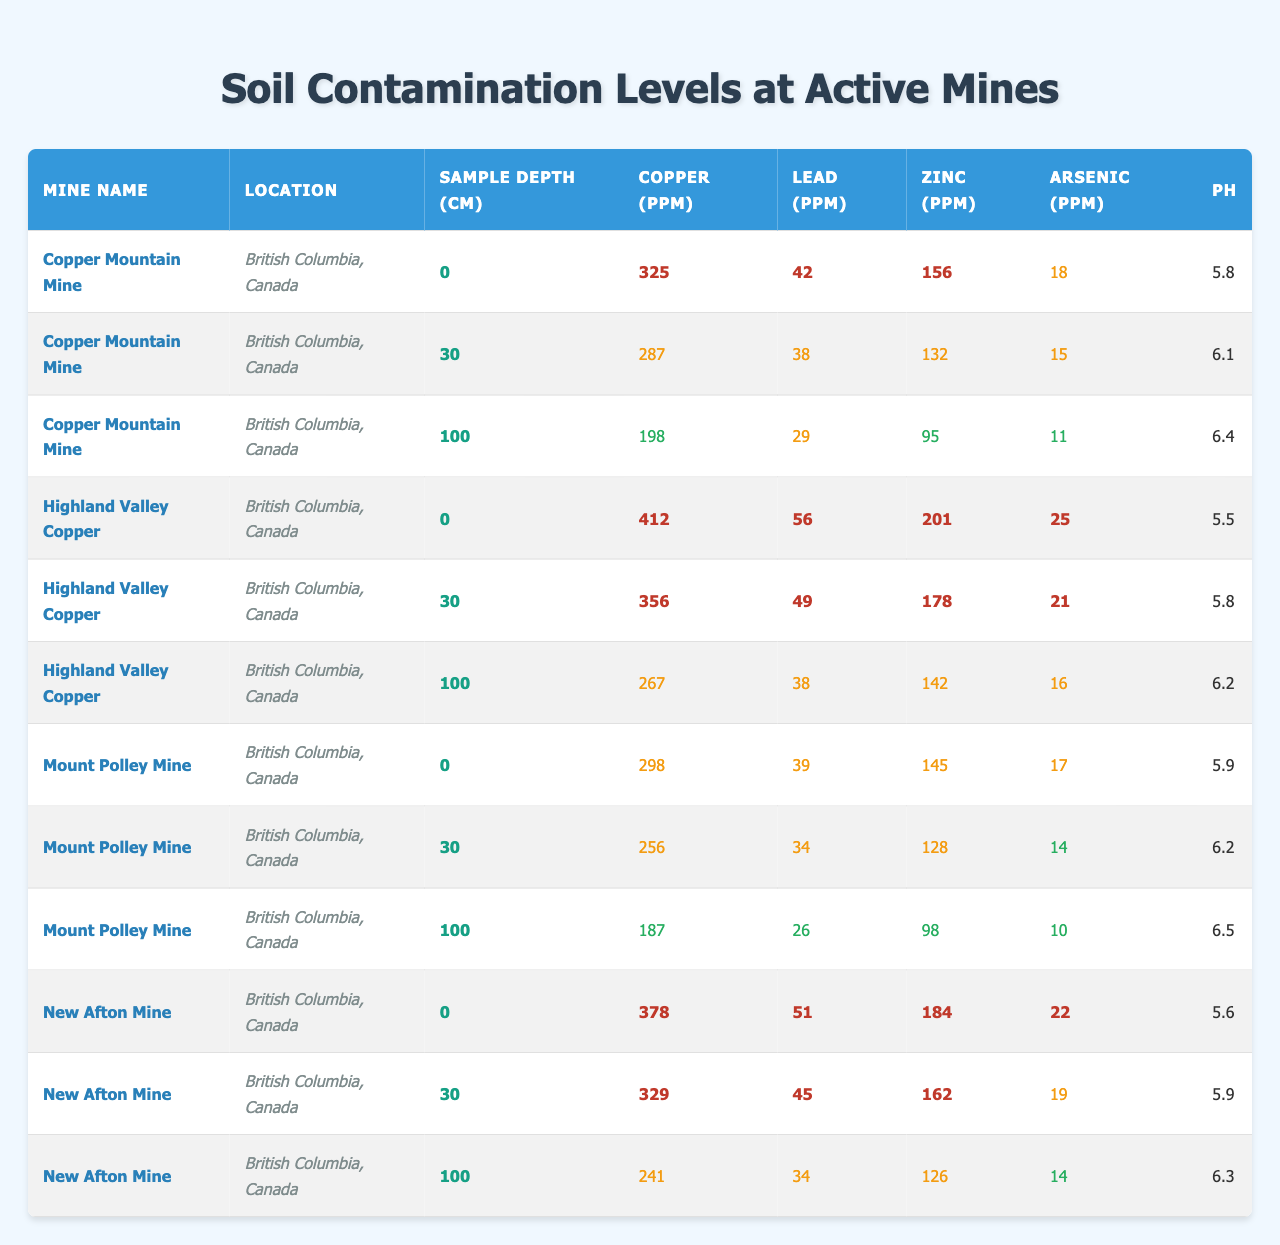What is the pH level recorded at Copper Mountain Mine at a depth of 100 cm? The pH level for Copper Mountain Mine at a depth of 100 cm is specifically listed in the table, where it shows a value of 6.4.
Answer: 6.4 Which mine shows the highest level of copper contamination at 30 cm depth? Looking at the table, Highland Valley Copper has the highest copper level at 30 cm with 356 ppm, compared to other mines at the same depth.
Answer: Highland Valley Copper What is the average arsenic contamination across all mines at a depth of 0 cm? By summing the arsenic levels at 0 cm for all four mines (18 + 25 + 17 + 22 = 82) and dividing by the number of mines (4), the average is calculated as 82/4 = 20.5.
Answer: 20.5 Is the lead contamination at Mount Polley Mine higher than that at New Afton Mine at 30 cm depth? Mount Polley Mine has 34 ppm of lead at 30 cm while New Afton Mine has 45 ppm at the same depth. Since 34 is less than 45, it confirms that the lead level at Mount Polley Mine is lower.
Answer: No At which depth does the New Afton Mine show a notable decrease in copper contamination from 0 cm to 100 cm? The New Afton Mine shows a decrease in copper from 378 ppm at 0 cm to 241 ppm at 100 cm. The difference (378 - 241) indicates a significant reduction of 137 ppm.
Answer: 100 cm What is the highest level of zinc contamination recorded, and at which mine and depth was it found? The table shows that the highest zinc contamination recorded is 201 ppm at Highland Valley Copper Mine at a depth of 0 cm.
Answer: Highland Valley Copper, 0 cm Are all mines showing an increase in pH level as the sampling depth increases? Reviewing the data, the pH levels for all mines either increase or remain the same as the depth increases, indicating a general trend of rising pH with depth.
Answer: Yes What is the combined total level of copper contamination from all mines at 0 cm depth? By adding the copper levels at 0 cm from all mines (325 + 412 + 298 + 378 = 1413), the combined total is found to be 1413 ppm.
Answer: 1413 Which mine shows the lowest level of lead contamination at any depth, and what is that level? Referring to the table, Mount Polley Mine shows the lowest level of lead contamination at 0 cm with 39 ppm, which is lower than all other recorded lead levels for that depth.
Answer: Mount Polley Mine, 39 ppm How does the zinc level at 100 cm depth compare between Copper Mountain Mine and Mount Polley Mine? At 100 cm depth, Copper Mountain Mine has 95 ppm of zinc, while Mount Polley Mine has 98 ppm; therefore, Mount Polley Mine has a slightly higher level of zinc contamination at that depth.
Answer: Mount Polley Mine has higher zinc 